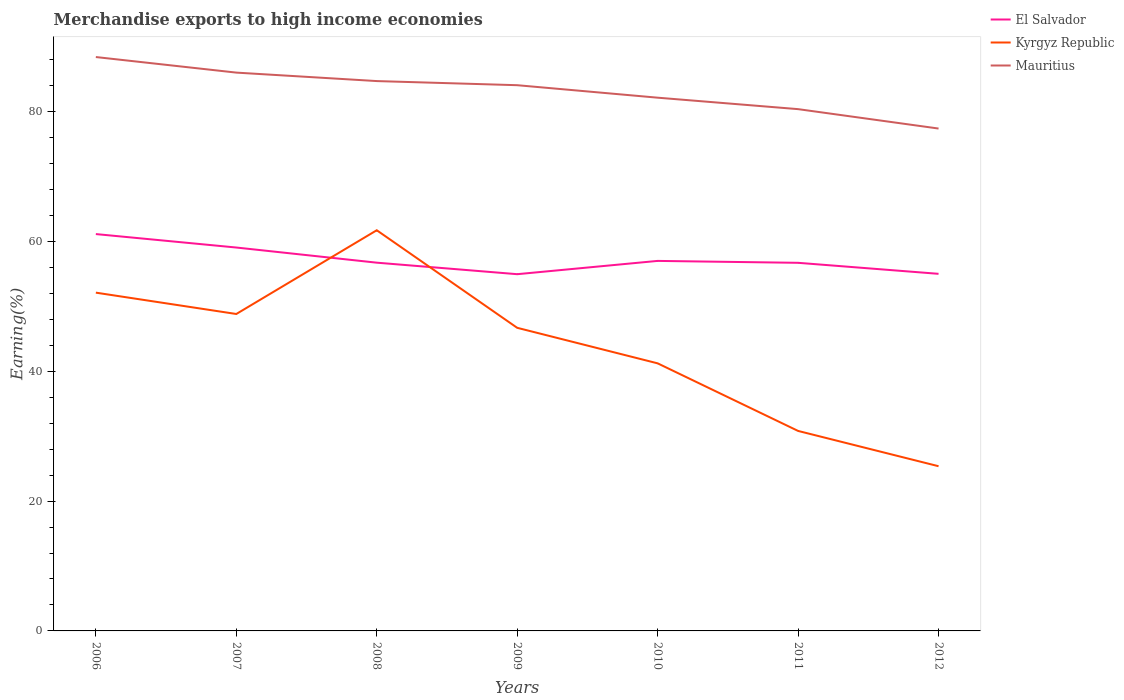Does the line corresponding to Kyrgyz Republic intersect with the line corresponding to Mauritius?
Keep it short and to the point. No. Is the number of lines equal to the number of legend labels?
Give a very brief answer. Yes. Across all years, what is the maximum percentage of amount earned from merchandise exports in Kyrgyz Republic?
Provide a succinct answer. 25.37. In which year was the percentage of amount earned from merchandise exports in El Salvador maximum?
Your response must be concise. 2009. What is the total percentage of amount earned from merchandise exports in Mauritius in the graph?
Provide a succinct answer. 2.4. What is the difference between the highest and the second highest percentage of amount earned from merchandise exports in El Salvador?
Give a very brief answer. 6.18. What is the difference between the highest and the lowest percentage of amount earned from merchandise exports in Kyrgyz Republic?
Offer a terse response. 4. Is the percentage of amount earned from merchandise exports in El Salvador strictly greater than the percentage of amount earned from merchandise exports in Kyrgyz Republic over the years?
Give a very brief answer. No. How many years are there in the graph?
Give a very brief answer. 7. Does the graph contain grids?
Provide a short and direct response. No. Where does the legend appear in the graph?
Give a very brief answer. Top right. How many legend labels are there?
Offer a very short reply. 3. What is the title of the graph?
Your response must be concise. Merchandise exports to high income economies. What is the label or title of the Y-axis?
Provide a succinct answer. Earning(%). What is the Earning(%) in El Salvador in 2006?
Give a very brief answer. 61.14. What is the Earning(%) in Kyrgyz Republic in 2006?
Ensure brevity in your answer.  52.11. What is the Earning(%) of Mauritius in 2006?
Offer a terse response. 88.41. What is the Earning(%) in El Salvador in 2007?
Your answer should be compact. 59.07. What is the Earning(%) in Kyrgyz Republic in 2007?
Keep it short and to the point. 48.83. What is the Earning(%) in Mauritius in 2007?
Your answer should be compact. 86.01. What is the Earning(%) in El Salvador in 2008?
Ensure brevity in your answer.  56.73. What is the Earning(%) in Kyrgyz Republic in 2008?
Offer a terse response. 61.73. What is the Earning(%) in Mauritius in 2008?
Provide a short and direct response. 84.71. What is the Earning(%) in El Salvador in 2009?
Provide a succinct answer. 54.96. What is the Earning(%) of Kyrgyz Republic in 2009?
Your answer should be compact. 46.7. What is the Earning(%) in Mauritius in 2009?
Your answer should be very brief. 84.08. What is the Earning(%) in El Salvador in 2010?
Give a very brief answer. 57.01. What is the Earning(%) in Kyrgyz Republic in 2010?
Give a very brief answer. 41.22. What is the Earning(%) in Mauritius in 2010?
Your answer should be compact. 82.15. What is the Earning(%) of El Salvador in 2011?
Your answer should be compact. 56.71. What is the Earning(%) of Kyrgyz Republic in 2011?
Your answer should be very brief. 30.81. What is the Earning(%) of Mauritius in 2011?
Ensure brevity in your answer.  80.39. What is the Earning(%) of El Salvador in 2012?
Provide a short and direct response. 55.01. What is the Earning(%) of Kyrgyz Republic in 2012?
Provide a succinct answer. 25.37. What is the Earning(%) in Mauritius in 2012?
Keep it short and to the point. 77.4. Across all years, what is the maximum Earning(%) of El Salvador?
Provide a short and direct response. 61.14. Across all years, what is the maximum Earning(%) in Kyrgyz Republic?
Provide a short and direct response. 61.73. Across all years, what is the maximum Earning(%) in Mauritius?
Your answer should be very brief. 88.41. Across all years, what is the minimum Earning(%) in El Salvador?
Ensure brevity in your answer.  54.96. Across all years, what is the minimum Earning(%) in Kyrgyz Republic?
Offer a very short reply. 25.37. Across all years, what is the minimum Earning(%) of Mauritius?
Your answer should be compact. 77.4. What is the total Earning(%) of El Salvador in the graph?
Your response must be concise. 400.63. What is the total Earning(%) in Kyrgyz Republic in the graph?
Offer a very short reply. 306.77. What is the total Earning(%) in Mauritius in the graph?
Provide a short and direct response. 583.15. What is the difference between the Earning(%) of El Salvador in 2006 and that in 2007?
Make the answer very short. 2.07. What is the difference between the Earning(%) in Kyrgyz Republic in 2006 and that in 2007?
Ensure brevity in your answer.  3.29. What is the difference between the Earning(%) in Mauritius in 2006 and that in 2007?
Keep it short and to the point. 2.4. What is the difference between the Earning(%) in El Salvador in 2006 and that in 2008?
Ensure brevity in your answer.  4.41. What is the difference between the Earning(%) in Kyrgyz Republic in 2006 and that in 2008?
Give a very brief answer. -9.61. What is the difference between the Earning(%) in Mauritius in 2006 and that in 2008?
Make the answer very short. 3.7. What is the difference between the Earning(%) of El Salvador in 2006 and that in 2009?
Provide a short and direct response. 6.18. What is the difference between the Earning(%) in Kyrgyz Republic in 2006 and that in 2009?
Your answer should be very brief. 5.42. What is the difference between the Earning(%) of Mauritius in 2006 and that in 2009?
Offer a very short reply. 4.34. What is the difference between the Earning(%) in El Salvador in 2006 and that in 2010?
Make the answer very short. 4.13. What is the difference between the Earning(%) in Kyrgyz Republic in 2006 and that in 2010?
Offer a terse response. 10.89. What is the difference between the Earning(%) of Mauritius in 2006 and that in 2010?
Keep it short and to the point. 6.26. What is the difference between the Earning(%) of El Salvador in 2006 and that in 2011?
Offer a terse response. 4.43. What is the difference between the Earning(%) in Kyrgyz Republic in 2006 and that in 2011?
Give a very brief answer. 21.3. What is the difference between the Earning(%) in Mauritius in 2006 and that in 2011?
Keep it short and to the point. 8.03. What is the difference between the Earning(%) of El Salvador in 2006 and that in 2012?
Keep it short and to the point. 6.13. What is the difference between the Earning(%) of Kyrgyz Republic in 2006 and that in 2012?
Provide a succinct answer. 26.74. What is the difference between the Earning(%) in Mauritius in 2006 and that in 2012?
Ensure brevity in your answer.  11.02. What is the difference between the Earning(%) in El Salvador in 2007 and that in 2008?
Give a very brief answer. 2.33. What is the difference between the Earning(%) of Kyrgyz Republic in 2007 and that in 2008?
Provide a short and direct response. -12.9. What is the difference between the Earning(%) in Mauritius in 2007 and that in 2008?
Offer a terse response. 1.3. What is the difference between the Earning(%) in El Salvador in 2007 and that in 2009?
Provide a short and direct response. 4.11. What is the difference between the Earning(%) of Kyrgyz Republic in 2007 and that in 2009?
Give a very brief answer. 2.13. What is the difference between the Earning(%) of Mauritius in 2007 and that in 2009?
Provide a succinct answer. 1.94. What is the difference between the Earning(%) in El Salvador in 2007 and that in 2010?
Give a very brief answer. 2.06. What is the difference between the Earning(%) of Kyrgyz Republic in 2007 and that in 2010?
Provide a succinct answer. 7.6. What is the difference between the Earning(%) in Mauritius in 2007 and that in 2010?
Keep it short and to the point. 3.86. What is the difference between the Earning(%) of El Salvador in 2007 and that in 2011?
Keep it short and to the point. 2.35. What is the difference between the Earning(%) in Kyrgyz Republic in 2007 and that in 2011?
Ensure brevity in your answer.  18.02. What is the difference between the Earning(%) of Mauritius in 2007 and that in 2011?
Make the answer very short. 5.63. What is the difference between the Earning(%) of El Salvador in 2007 and that in 2012?
Provide a short and direct response. 4.05. What is the difference between the Earning(%) of Kyrgyz Republic in 2007 and that in 2012?
Provide a short and direct response. 23.45. What is the difference between the Earning(%) in Mauritius in 2007 and that in 2012?
Your answer should be very brief. 8.62. What is the difference between the Earning(%) of El Salvador in 2008 and that in 2009?
Give a very brief answer. 1.77. What is the difference between the Earning(%) of Kyrgyz Republic in 2008 and that in 2009?
Your answer should be very brief. 15.03. What is the difference between the Earning(%) of Mauritius in 2008 and that in 2009?
Give a very brief answer. 0.64. What is the difference between the Earning(%) of El Salvador in 2008 and that in 2010?
Keep it short and to the point. -0.27. What is the difference between the Earning(%) in Kyrgyz Republic in 2008 and that in 2010?
Provide a succinct answer. 20.51. What is the difference between the Earning(%) of Mauritius in 2008 and that in 2010?
Your response must be concise. 2.56. What is the difference between the Earning(%) in El Salvador in 2008 and that in 2011?
Keep it short and to the point. 0.02. What is the difference between the Earning(%) in Kyrgyz Republic in 2008 and that in 2011?
Make the answer very short. 30.92. What is the difference between the Earning(%) in Mauritius in 2008 and that in 2011?
Give a very brief answer. 4.32. What is the difference between the Earning(%) of El Salvador in 2008 and that in 2012?
Your response must be concise. 1.72. What is the difference between the Earning(%) in Kyrgyz Republic in 2008 and that in 2012?
Provide a short and direct response. 36.35. What is the difference between the Earning(%) in Mauritius in 2008 and that in 2012?
Provide a short and direct response. 7.31. What is the difference between the Earning(%) of El Salvador in 2009 and that in 2010?
Offer a very short reply. -2.05. What is the difference between the Earning(%) in Kyrgyz Republic in 2009 and that in 2010?
Make the answer very short. 5.47. What is the difference between the Earning(%) of Mauritius in 2009 and that in 2010?
Give a very brief answer. 1.92. What is the difference between the Earning(%) in El Salvador in 2009 and that in 2011?
Your answer should be very brief. -1.75. What is the difference between the Earning(%) in Kyrgyz Republic in 2009 and that in 2011?
Offer a terse response. 15.89. What is the difference between the Earning(%) in Mauritius in 2009 and that in 2011?
Your answer should be very brief. 3.69. What is the difference between the Earning(%) of El Salvador in 2009 and that in 2012?
Your answer should be compact. -0.05. What is the difference between the Earning(%) in Kyrgyz Republic in 2009 and that in 2012?
Provide a succinct answer. 21.32. What is the difference between the Earning(%) in Mauritius in 2009 and that in 2012?
Keep it short and to the point. 6.68. What is the difference between the Earning(%) of El Salvador in 2010 and that in 2011?
Keep it short and to the point. 0.29. What is the difference between the Earning(%) of Kyrgyz Republic in 2010 and that in 2011?
Ensure brevity in your answer.  10.41. What is the difference between the Earning(%) in Mauritius in 2010 and that in 2011?
Keep it short and to the point. 1.77. What is the difference between the Earning(%) in El Salvador in 2010 and that in 2012?
Provide a short and direct response. 1.99. What is the difference between the Earning(%) of Kyrgyz Republic in 2010 and that in 2012?
Offer a very short reply. 15.85. What is the difference between the Earning(%) of Mauritius in 2010 and that in 2012?
Your answer should be very brief. 4.76. What is the difference between the Earning(%) in El Salvador in 2011 and that in 2012?
Offer a very short reply. 1.7. What is the difference between the Earning(%) in Kyrgyz Republic in 2011 and that in 2012?
Provide a short and direct response. 5.44. What is the difference between the Earning(%) of Mauritius in 2011 and that in 2012?
Your answer should be compact. 2.99. What is the difference between the Earning(%) in El Salvador in 2006 and the Earning(%) in Kyrgyz Republic in 2007?
Offer a very short reply. 12.31. What is the difference between the Earning(%) of El Salvador in 2006 and the Earning(%) of Mauritius in 2007?
Offer a terse response. -24.87. What is the difference between the Earning(%) in Kyrgyz Republic in 2006 and the Earning(%) in Mauritius in 2007?
Provide a short and direct response. -33.9. What is the difference between the Earning(%) in El Salvador in 2006 and the Earning(%) in Kyrgyz Republic in 2008?
Your response must be concise. -0.59. What is the difference between the Earning(%) of El Salvador in 2006 and the Earning(%) of Mauritius in 2008?
Make the answer very short. -23.57. What is the difference between the Earning(%) in Kyrgyz Republic in 2006 and the Earning(%) in Mauritius in 2008?
Give a very brief answer. -32.6. What is the difference between the Earning(%) of El Salvador in 2006 and the Earning(%) of Kyrgyz Republic in 2009?
Provide a short and direct response. 14.44. What is the difference between the Earning(%) of El Salvador in 2006 and the Earning(%) of Mauritius in 2009?
Keep it short and to the point. -22.94. What is the difference between the Earning(%) of Kyrgyz Republic in 2006 and the Earning(%) of Mauritius in 2009?
Make the answer very short. -31.96. What is the difference between the Earning(%) of El Salvador in 2006 and the Earning(%) of Kyrgyz Republic in 2010?
Provide a short and direct response. 19.92. What is the difference between the Earning(%) in El Salvador in 2006 and the Earning(%) in Mauritius in 2010?
Offer a terse response. -21.01. What is the difference between the Earning(%) of Kyrgyz Republic in 2006 and the Earning(%) of Mauritius in 2010?
Your answer should be very brief. -30.04. What is the difference between the Earning(%) in El Salvador in 2006 and the Earning(%) in Kyrgyz Republic in 2011?
Your answer should be very brief. 30.33. What is the difference between the Earning(%) in El Salvador in 2006 and the Earning(%) in Mauritius in 2011?
Provide a succinct answer. -19.25. What is the difference between the Earning(%) in Kyrgyz Republic in 2006 and the Earning(%) in Mauritius in 2011?
Make the answer very short. -28.27. What is the difference between the Earning(%) of El Salvador in 2006 and the Earning(%) of Kyrgyz Republic in 2012?
Provide a short and direct response. 35.77. What is the difference between the Earning(%) in El Salvador in 2006 and the Earning(%) in Mauritius in 2012?
Keep it short and to the point. -16.26. What is the difference between the Earning(%) in Kyrgyz Republic in 2006 and the Earning(%) in Mauritius in 2012?
Offer a very short reply. -25.28. What is the difference between the Earning(%) in El Salvador in 2007 and the Earning(%) in Kyrgyz Republic in 2008?
Offer a very short reply. -2.66. What is the difference between the Earning(%) in El Salvador in 2007 and the Earning(%) in Mauritius in 2008?
Offer a very short reply. -25.64. What is the difference between the Earning(%) in Kyrgyz Republic in 2007 and the Earning(%) in Mauritius in 2008?
Provide a succinct answer. -35.88. What is the difference between the Earning(%) in El Salvador in 2007 and the Earning(%) in Kyrgyz Republic in 2009?
Keep it short and to the point. 12.37. What is the difference between the Earning(%) in El Salvador in 2007 and the Earning(%) in Mauritius in 2009?
Keep it short and to the point. -25.01. What is the difference between the Earning(%) in Kyrgyz Republic in 2007 and the Earning(%) in Mauritius in 2009?
Your response must be concise. -35.25. What is the difference between the Earning(%) of El Salvador in 2007 and the Earning(%) of Kyrgyz Republic in 2010?
Your answer should be very brief. 17.84. What is the difference between the Earning(%) of El Salvador in 2007 and the Earning(%) of Mauritius in 2010?
Provide a short and direct response. -23.09. What is the difference between the Earning(%) in Kyrgyz Republic in 2007 and the Earning(%) in Mauritius in 2010?
Make the answer very short. -33.33. What is the difference between the Earning(%) of El Salvador in 2007 and the Earning(%) of Kyrgyz Republic in 2011?
Make the answer very short. 28.26. What is the difference between the Earning(%) in El Salvador in 2007 and the Earning(%) in Mauritius in 2011?
Offer a terse response. -21.32. What is the difference between the Earning(%) in Kyrgyz Republic in 2007 and the Earning(%) in Mauritius in 2011?
Provide a short and direct response. -31.56. What is the difference between the Earning(%) in El Salvador in 2007 and the Earning(%) in Kyrgyz Republic in 2012?
Provide a succinct answer. 33.69. What is the difference between the Earning(%) in El Salvador in 2007 and the Earning(%) in Mauritius in 2012?
Give a very brief answer. -18.33. What is the difference between the Earning(%) in Kyrgyz Republic in 2007 and the Earning(%) in Mauritius in 2012?
Provide a short and direct response. -28.57. What is the difference between the Earning(%) of El Salvador in 2008 and the Earning(%) of Kyrgyz Republic in 2009?
Offer a terse response. 10.04. What is the difference between the Earning(%) in El Salvador in 2008 and the Earning(%) in Mauritius in 2009?
Your answer should be very brief. -27.34. What is the difference between the Earning(%) in Kyrgyz Republic in 2008 and the Earning(%) in Mauritius in 2009?
Keep it short and to the point. -22.35. What is the difference between the Earning(%) in El Salvador in 2008 and the Earning(%) in Kyrgyz Republic in 2010?
Make the answer very short. 15.51. What is the difference between the Earning(%) of El Salvador in 2008 and the Earning(%) of Mauritius in 2010?
Provide a short and direct response. -25.42. What is the difference between the Earning(%) in Kyrgyz Republic in 2008 and the Earning(%) in Mauritius in 2010?
Offer a very short reply. -20.42. What is the difference between the Earning(%) of El Salvador in 2008 and the Earning(%) of Kyrgyz Republic in 2011?
Your answer should be compact. 25.92. What is the difference between the Earning(%) in El Salvador in 2008 and the Earning(%) in Mauritius in 2011?
Give a very brief answer. -23.65. What is the difference between the Earning(%) in Kyrgyz Republic in 2008 and the Earning(%) in Mauritius in 2011?
Make the answer very short. -18.66. What is the difference between the Earning(%) of El Salvador in 2008 and the Earning(%) of Kyrgyz Republic in 2012?
Provide a succinct answer. 31.36. What is the difference between the Earning(%) of El Salvador in 2008 and the Earning(%) of Mauritius in 2012?
Keep it short and to the point. -20.66. What is the difference between the Earning(%) in Kyrgyz Republic in 2008 and the Earning(%) in Mauritius in 2012?
Offer a terse response. -15.67. What is the difference between the Earning(%) in El Salvador in 2009 and the Earning(%) in Kyrgyz Republic in 2010?
Provide a short and direct response. 13.74. What is the difference between the Earning(%) in El Salvador in 2009 and the Earning(%) in Mauritius in 2010?
Your response must be concise. -27.19. What is the difference between the Earning(%) of Kyrgyz Republic in 2009 and the Earning(%) of Mauritius in 2010?
Provide a succinct answer. -35.46. What is the difference between the Earning(%) of El Salvador in 2009 and the Earning(%) of Kyrgyz Republic in 2011?
Make the answer very short. 24.15. What is the difference between the Earning(%) of El Salvador in 2009 and the Earning(%) of Mauritius in 2011?
Offer a terse response. -25.43. What is the difference between the Earning(%) of Kyrgyz Republic in 2009 and the Earning(%) of Mauritius in 2011?
Provide a succinct answer. -33.69. What is the difference between the Earning(%) in El Salvador in 2009 and the Earning(%) in Kyrgyz Republic in 2012?
Offer a very short reply. 29.59. What is the difference between the Earning(%) of El Salvador in 2009 and the Earning(%) of Mauritius in 2012?
Your answer should be compact. -22.44. What is the difference between the Earning(%) in Kyrgyz Republic in 2009 and the Earning(%) in Mauritius in 2012?
Offer a very short reply. -30.7. What is the difference between the Earning(%) in El Salvador in 2010 and the Earning(%) in Kyrgyz Republic in 2011?
Ensure brevity in your answer.  26.2. What is the difference between the Earning(%) of El Salvador in 2010 and the Earning(%) of Mauritius in 2011?
Provide a succinct answer. -23.38. What is the difference between the Earning(%) in Kyrgyz Republic in 2010 and the Earning(%) in Mauritius in 2011?
Give a very brief answer. -39.16. What is the difference between the Earning(%) of El Salvador in 2010 and the Earning(%) of Kyrgyz Republic in 2012?
Offer a very short reply. 31.63. What is the difference between the Earning(%) in El Salvador in 2010 and the Earning(%) in Mauritius in 2012?
Offer a very short reply. -20.39. What is the difference between the Earning(%) of Kyrgyz Republic in 2010 and the Earning(%) of Mauritius in 2012?
Your answer should be compact. -36.17. What is the difference between the Earning(%) in El Salvador in 2011 and the Earning(%) in Kyrgyz Republic in 2012?
Make the answer very short. 31.34. What is the difference between the Earning(%) of El Salvador in 2011 and the Earning(%) of Mauritius in 2012?
Offer a very short reply. -20.69. What is the difference between the Earning(%) of Kyrgyz Republic in 2011 and the Earning(%) of Mauritius in 2012?
Make the answer very short. -46.59. What is the average Earning(%) in El Salvador per year?
Provide a short and direct response. 57.23. What is the average Earning(%) in Kyrgyz Republic per year?
Your response must be concise. 43.82. What is the average Earning(%) in Mauritius per year?
Offer a very short reply. 83.31. In the year 2006, what is the difference between the Earning(%) in El Salvador and Earning(%) in Kyrgyz Republic?
Give a very brief answer. 9.03. In the year 2006, what is the difference between the Earning(%) of El Salvador and Earning(%) of Mauritius?
Provide a short and direct response. -27.27. In the year 2006, what is the difference between the Earning(%) of Kyrgyz Republic and Earning(%) of Mauritius?
Make the answer very short. -36.3. In the year 2007, what is the difference between the Earning(%) of El Salvador and Earning(%) of Kyrgyz Republic?
Keep it short and to the point. 10.24. In the year 2007, what is the difference between the Earning(%) of El Salvador and Earning(%) of Mauritius?
Make the answer very short. -26.95. In the year 2007, what is the difference between the Earning(%) of Kyrgyz Republic and Earning(%) of Mauritius?
Ensure brevity in your answer.  -37.19. In the year 2008, what is the difference between the Earning(%) in El Salvador and Earning(%) in Kyrgyz Republic?
Give a very brief answer. -5. In the year 2008, what is the difference between the Earning(%) in El Salvador and Earning(%) in Mauritius?
Your response must be concise. -27.98. In the year 2008, what is the difference between the Earning(%) of Kyrgyz Republic and Earning(%) of Mauritius?
Make the answer very short. -22.98. In the year 2009, what is the difference between the Earning(%) in El Salvador and Earning(%) in Kyrgyz Republic?
Offer a very short reply. 8.26. In the year 2009, what is the difference between the Earning(%) in El Salvador and Earning(%) in Mauritius?
Make the answer very short. -29.12. In the year 2009, what is the difference between the Earning(%) of Kyrgyz Republic and Earning(%) of Mauritius?
Offer a terse response. -37.38. In the year 2010, what is the difference between the Earning(%) in El Salvador and Earning(%) in Kyrgyz Republic?
Provide a succinct answer. 15.78. In the year 2010, what is the difference between the Earning(%) in El Salvador and Earning(%) in Mauritius?
Keep it short and to the point. -25.15. In the year 2010, what is the difference between the Earning(%) in Kyrgyz Republic and Earning(%) in Mauritius?
Your answer should be compact. -40.93. In the year 2011, what is the difference between the Earning(%) in El Salvador and Earning(%) in Kyrgyz Republic?
Provide a short and direct response. 25.9. In the year 2011, what is the difference between the Earning(%) in El Salvador and Earning(%) in Mauritius?
Make the answer very short. -23.67. In the year 2011, what is the difference between the Earning(%) in Kyrgyz Republic and Earning(%) in Mauritius?
Offer a terse response. -49.58. In the year 2012, what is the difference between the Earning(%) in El Salvador and Earning(%) in Kyrgyz Republic?
Keep it short and to the point. 29.64. In the year 2012, what is the difference between the Earning(%) of El Salvador and Earning(%) of Mauritius?
Ensure brevity in your answer.  -22.38. In the year 2012, what is the difference between the Earning(%) of Kyrgyz Republic and Earning(%) of Mauritius?
Provide a short and direct response. -52.02. What is the ratio of the Earning(%) of El Salvador in 2006 to that in 2007?
Your answer should be very brief. 1.04. What is the ratio of the Earning(%) of Kyrgyz Republic in 2006 to that in 2007?
Offer a very short reply. 1.07. What is the ratio of the Earning(%) of Mauritius in 2006 to that in 2007?
Your answer should be compact. 1.03. What is the ratio of the Earning(%) of El Salvador in 2006 to that in 2008?
Ensure brevity in your answer.  1.08. What is the ratio of the Earning(%) of Kyrgyz Republic in 2006 to that in 2008?
Offer a very short reply. 0.84. What is the ratio of the Earning(%) of Mauritius in 2006 to that in 2008?
Keep it short and to the point. 1.04. What is the ratio of the Earning(%) in El Salvador in 2006 to that in 2009?
Make the answer very short. 1.11. What is the ratio of the Earning(%) in Kyrgyz Republic in 2006 to that in 2009?
Ensure brevity in your answer.  1.12. What is the ratio of the Earning(%) in Mauritius in 2006 to that in 2009?
Your answer should be compact. 1.05. What is the ratio of the Earning(%) of El Salvador in 2006 to that in 2010?
Provide a succinct answer. 1.07. What is the ratio of the Earning(%) of Kyrgyz Republic in 2006 to that in 2010?
Provide a short and direct response. 1.26. What is the ratio of the Earning(%) in Mauritius in 2006 to that in 2010?
Provide a succinct answer. 1.08. What is the ratio of the Earning(%) in El Salvador in 2006 to that in 2011?
Your response must be concise. 1.08. What is the ratio of the Earning(%) of Kyrgyz Republic in 2006 to that in 2011?
Provide a short and direct response. 1.69. What is the ratio of the Earning(%) of Mauritius in 2006 to that in 2011?
Your answer should be very brief. 1.1. What is the ratio of the Earning(%) in El Salvador in 2006 to that in 2012?
Your response must be concise. 1.11. What is the ratio of the Earning(%) in Kyrgyz Republic in 2006 to that in 2012?
Give a very brief answer. 2.05. What is the ratio of the Earning(%) in Mauritius in 2006 to that in 2012?
Provide a succinct answer. 1.14. What is the ratio of the Earning(%) in El Salvador in 2007 to that in 2008?
Provide a succinct answer. 1.04. What is the ratio of the Earning(%) in Kyrgyz Republic in 2007 to that in 2008?
Your answer should be very brief. 0.79. What is the ratio of the Earning(%) of Mauritius in 2007 to that in 2008?
Your answer should be very brief. 1.02. What is the ratio of the Earning(%) of El Salvador in 2007 to that in 2009?
Keep it short and to the point. 1.07. What is the ratio of the Earning(%) of Kyrgyz Republic in 2007 to that in 2009?
Your answer should be compact. 1.05. What is the ratio of the Earning(%) of Mauritius in 2007 to that in 2009?
Give a very brief answer. 1.02. What is the ratio of the Earning(%) in El Salvador in 2007 to that in 2010?
Ensure brevity in your answer.  1.04. What is the ratio of the Earning(%) in Kyrgyz Republic in 2007 to that in 2010?
Provide a succinct answer. 1.18. What is the ratio of the Earning(%) of Mauritius in 2007 to that in 2010?
Make the answer very short. 1.05. What is the ratio of the Earning(%) of El Salvador in 2007 to that in 2011?
Keep it short and to the point. 1.04. What is the ratio of the Earning(%) in Kyrgyz Republic in 2007 to that in 2011?
Ensure brevity in your answer.  1.58. What is the ratio of the Earning(%) of Mauritius in 2007 to that in 2011?
Provide a short and direct response. 1.07. What is the ratio of the Earning(%) of El Salvador in 2007 to that in 2012?
Your answer should be compact. 1.07. What is the ratio of the Earning(%) of Kyrgyz Republic in 2007 to that in 2012?
Offer a very short reply. 1.92. What is the ratio of the Earning(%) in Mauritius in 2007 to that in 2012?
Make the answer very short. 1.11. What is the ratio of the Earning(%) in El Salvador in 2008 to that in 2009?
Your answer should be compact. 1.03. What is the ratio of the Earning(%) of Kyrgyz Republic in 2008 to that in 2009?
Your response must be concise. 1.32. What is the ratio of the Earning(%) of Mauritius in 2008 to that in 2009?
Make the answer very short. 1.01. What is the ratio of the Earning(%) of El Salvador in 2008 to that in 2010?
Provide a short and direct response. 1. What is the ratio of the Earning(%) of Kyrgyz Republic in 2008 to that in 2010?
Keep it short and to the point. 1.5. What is the ratio of the Earning(%) in Mauritius in 2008 to that in 2010?
Offer a terse response. 1.03. What is the ratio of the Earning(%) of Kyrgyz Republic in 2008 to that in 2011?
Your response must be concise. 2. What is the ratio of the Earning(%) of Mauritius in 2008 to that in 2011?
Offer a very short reply. 1.05. What is the ratio of the Earning(%) of El Salvador in 2008 to that in 2012?
Your answer should be compact. 1.03. What is the ratio of the Earning(%) in Kyrgyz Republic in 2008 to that in 2012?
Ensure brevity in your answer.  2.43. What is the ratio of the Earning(%) of Mauritius in 2008 to that in 2012?
Your answer should be compact. 1.09. What is the ratio of the Earning(%) of El Salvador in 2009 to that in 2010?
Ensure brevity in your answer.  0.96. What is the ratio of the Earning(%) of Kyrgyz Republic in 2009 to that in 2010?
Your answer should be very brief. 1.13. What is the ratio of the Earning(%) in Mauritius in 2009 to that in 2010?
Ensure brevity in your answer.  1.02. What is the ratio of the Earning(%) in El Salvador in 2009 to that in 2011?
Offer a terse response. 0.97. What is the ratio of the Earning(%) in Kyrgyz Republic in 2009 to that in 2011?
Your answer should be compact. 1.52. What is the ratio of the Earning(%) of Mauritius in 2009 to that in 2011?
Your answer should be compact. 1.05. What is the ratio of the Earning(%) in Kyrgyz Republic in 2009 to that in 2012?
Give a very brief answer. 1.84. What is the ratio of the Earning(%) in Mauritius in 2009 to that in 2012?
Offer a very short reply. 1.09. What is the ratio of the Earning(%) in Kyrgyz Republic in 2010 to that in 2011?
Provide a succinct answer. 1.34. What is the ratio of the Earning(%) of Mauritius in 2010 to that in 2011?
Keep it short and to the point. 1.02. What is the ratio of the Earning(%) of El Salvador in 2010 to that in 2012?
Provide a short and direct response. 1.04. What is the ratio of the Earning(%) in Kyrgyz Republic in 2010 to that in 2012?
Provide a succinct answer. 1.62. What is the ratio of the Earning(%) in Mauritius in 2010 to that in 2012?
Give a very brief answer. 1.06. What is the ratio of the Earning(%) of El Salvador in 2011 to that in 2012?
Keep it short and to the point. 1.03. What is the ratio of the Earning(%) in Kyrgyz Republic in 2011 to that in 2012?
Provide a short and direct response. 1.21. What is the ratio of the Earning(%) of Mauritius in 2011 to that in 2012?
Give a very brief answer. 1.04. What is the difference between the highest and the second highest Earning(%) of El Salvador?
Offer a very short reply. 2.07. What is the difference between the highest and the second highest Earning(%) in Kyrgyz Republic?
Provide a succinct answer. 9.61. What is the difference between the highest and the second highest Earning(%) in Mauritius?
Give a very brief answer. 2.4. What is the difference between the highest and the lowest Earning(%) of El Salvador?
Your answer should be very brief. 6.18. What is the difference between the highest and the lowest Earning(%) of Kyrgyz Republic?
Offer a terse response. 36.35. What is the difference between the highest and the lowest Earning(%) of Mauritius?
Provide a succinct answer. 11.02. 